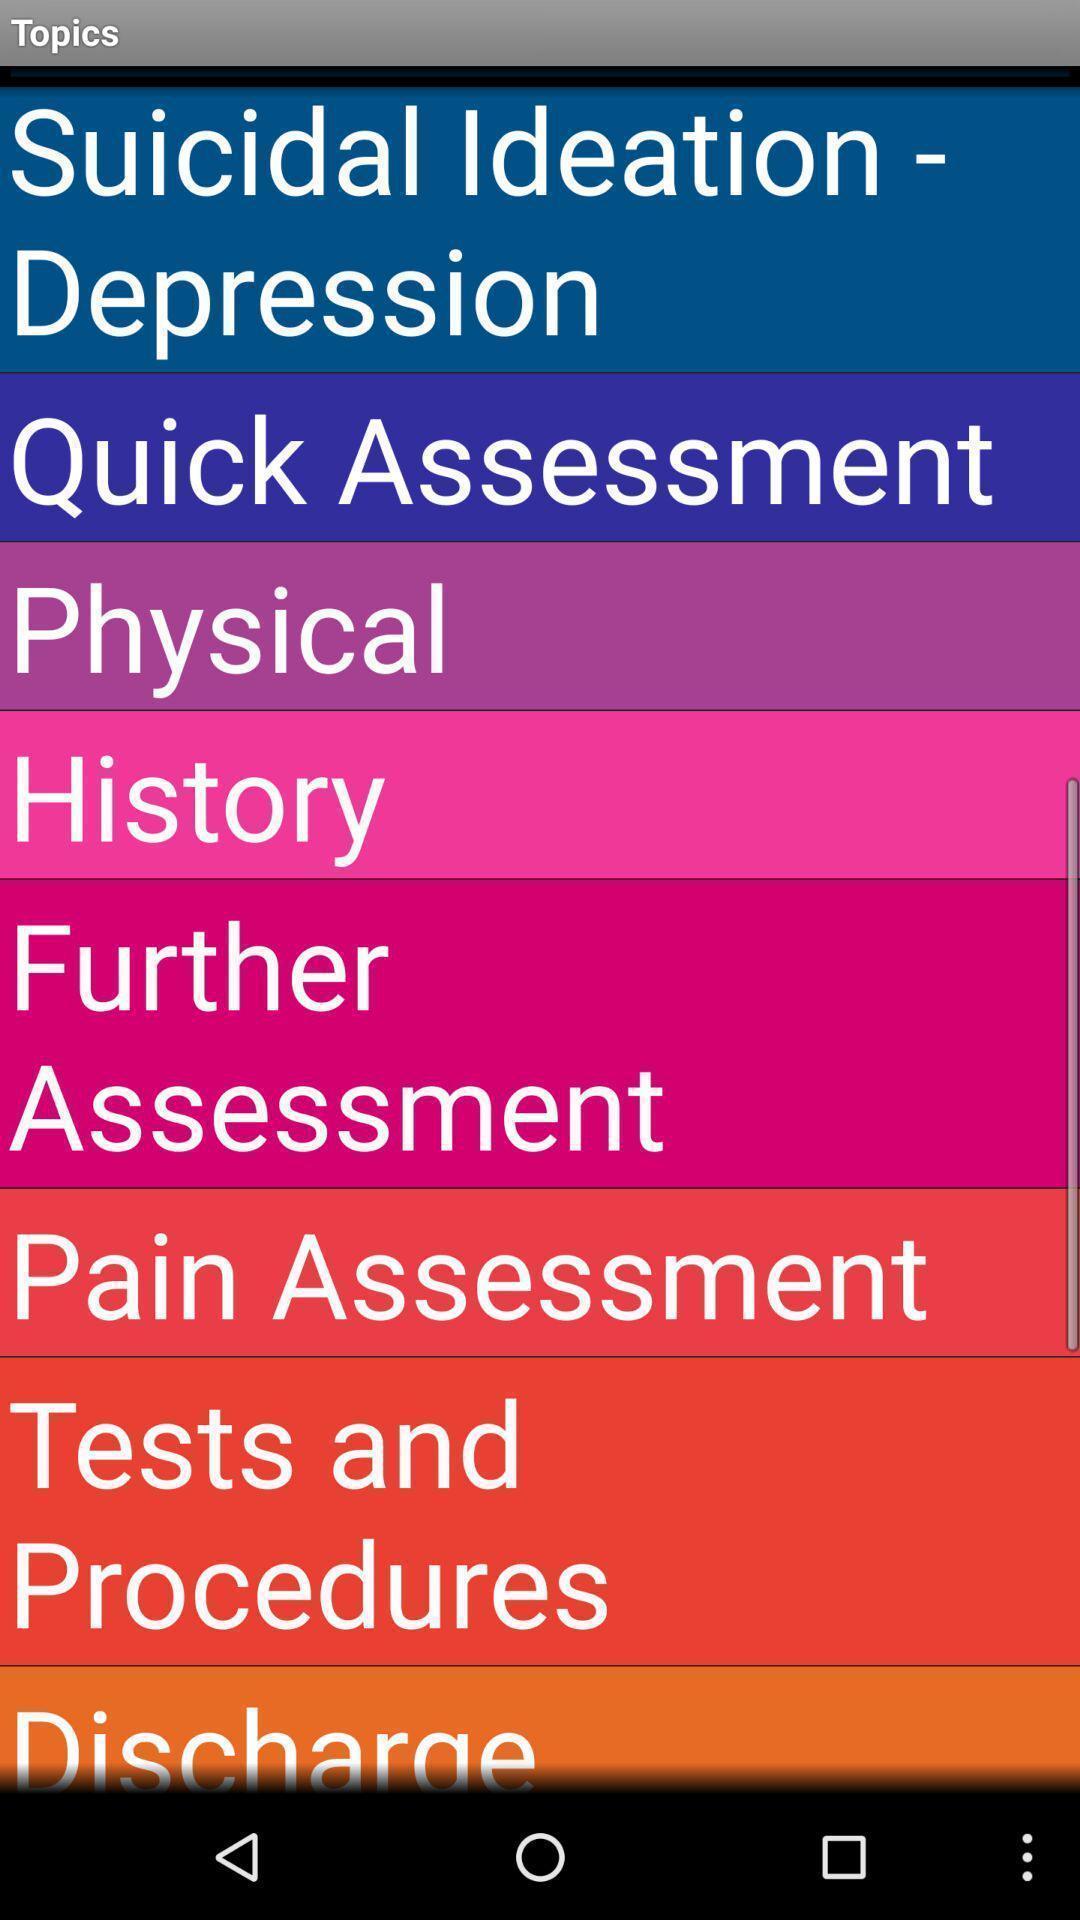Summarize the main components in this picture. Page displaying with list of topics. 